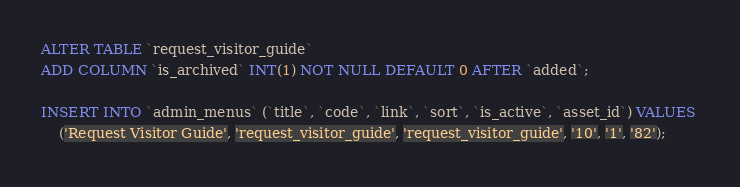Convert code to text. <code><loc_0><loc_0><loc_500><loc_500><_SQL_>ALTER TABLE `request_visitor_guide` 
ADD COLUMN `is_archived` INT(1) NOT NULL DEFAULT 0 AFTER `added`;

INSERT INTO `admin_menus` (`title`, `code`, `link`, `sort`, `is_active`, `asset_id`) VALUES 
	('Request Visitor Guide', 'request_visitor_guide', 'request_visitor_guide', '10', '1', '82');

</code> 